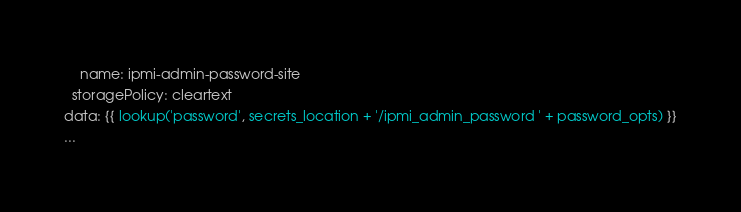Convert code to text. <code><loc_0><loc_0><loc_500><loc_500><_YAML_>    name: ipmi-admin-password-site
  storagePolicy: cleartext
data: {{ lookup('password', secrets_location + '/ipmi_admin_password ' + password_opts) }}
...
</code> 